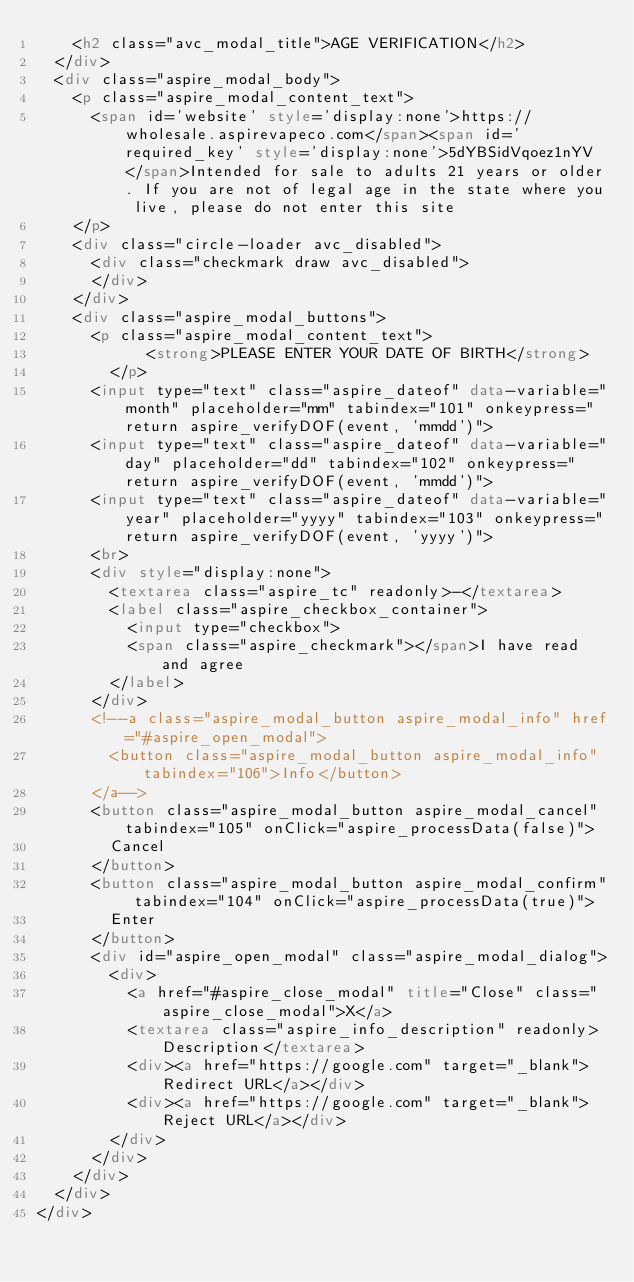Convert code to text. <code><loc_0><loc_0><loc_500><loc_500><_HTML_>		<h2 class="avc_modal_title">AGE VERIFICATION</h2>
	</div>
	<div class="aspire_modal_body">
		<p class="aspire_modal_content_text">
			<span id='website' style='display:none'>https://wholesale.aspirevapeco.com</span><span id='required_key' style='display:none'>5dYBSidVqoez1nYV</span>Intended for sale to adults 21 years or older. If you are not of legal age in the state where you live, please do not enter this site
		</p>
		<div class="circle-loader avc_disabled">
			<div class="checkmark draw avc_disabled">
			</div>
		</div>
		<div class="aspire_modal_buttons">
			<p class="aspire_modal_content_text">
		        <strong>PLEASE ENTER YOUR DATE OF BIRTH</strong>
		    </p>
			<input type="text" class="aspire_dateof" data-variable="month" placeholder="mm" tabindex="101" onkeypress="return aspire_verifyDOF(event, 'mmdd')">
			<input type="text" class="aspire_dateof" data-variable="day" placeholder="dd" tabindex="102" onkeypress="return aspire_verifyDOF(event, 'mmdd')">
			<input type="text" class="aspire_dateof" data-variable="year" placeholder="yyyy" tabindex="103" onkeypress="return aspire_verifyDOF(event, 'yyyy')">
			<br>
			<div style="display:none">
				<textarea class="aspire_tc" readonly>-</textarea>
				<label class="aspire_checkbox_container">
				  <input type="checkbox">
				  <span class="aspire_checkmark"></span>I have read and agree
				</label>
			</div>
			<!--a class="aspire_modal_button aspire_modal_info" href="#aspire_open_modal">
				<button class="aspire_modal_button aspire_modal_info" tabindex="106">Info</button>
			</a-->
			<button class="aspire_modal_button aspire_modal_cancel" tabindex="105" onClick="aspire_processData(false)">
				Cancel
			</button>
			<button class="aspire_modal_button aspire_modal_confirm" tabindex="104" onClick="aspire_processData(true)">
				Enter
			</button>
			<div id="aspire_open_modal" class="aspire_modal_dialog">
				<div>
					<a href="#aspire_close_modal" title="Close" class="aspire_close_modal">X</a>
					<textarea class="aspire_info_description" readonly>Description</textarea>
					<div><a href="https://google.com" target="_blank">Redirect URL</a></div>
					<div><a href="https://google.com" target="_blank">Reject URL</a></div>
				</div>
			</div>	
		</div>
	</div>
</div></code> 